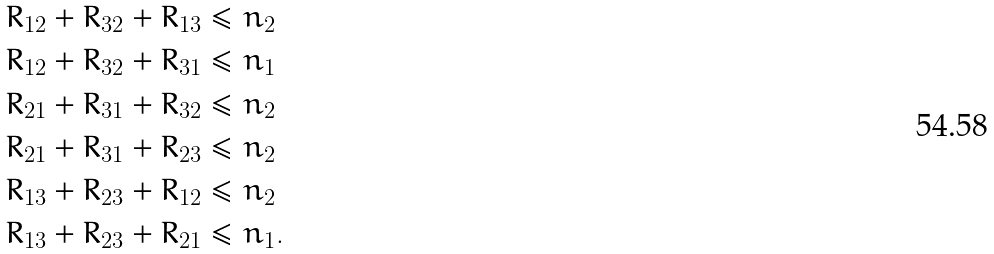<formula> <loc_0><loc_0><loc_500><loc_500>R _ { 1 2 } + R _ { 3 2 } + R _ { 1 3 } & \leq n _ { 2 } \\ R _ { 1 2 } + R _ { 3 2 } + R _ { 3 1 } & \leq n _ { 1 } \\ R _ { 2 1 } + R _ { 3 1 } + R _ { 3 2 } & \leq n _ { 2 } \\ R _ { 2 1 } + R _ { 3 1 } + R _ { 2 3 } & \leq n _ { 2 } \\ R _ { 1 3 } + R _ { 2 3 } + R _ { 1 2 } & \leq n _ { 2 } \\ R _ { 1 3 } + R _ { 2 3 } + R _ { 2 1 } & \leq n _ { 1 } .</formula> 